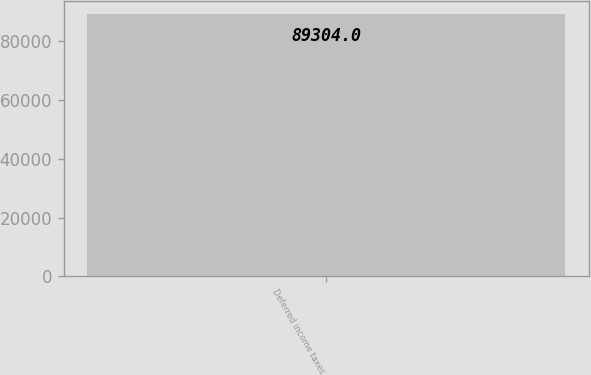<chart> <loc_0><loc_0><loc_500><loc_500><bar_chart><fcel>Deferred income taxes<nl><fcel>89304<nl></chart> 